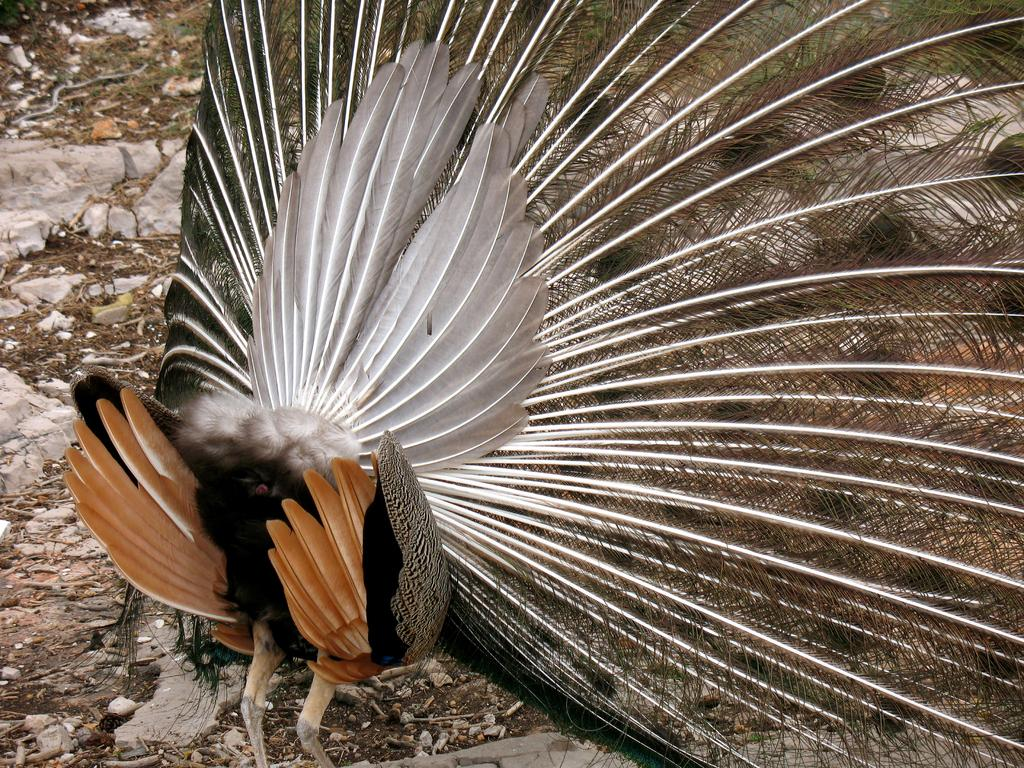What type of animal is in the picture? There is a peacock in the picture. What can be seen on the ground in the picture? There are stones and dried leaves on the ground. What type of tank is visible in the picture? There is no tank present in the picture; it features a peacock and elements on the ground. 